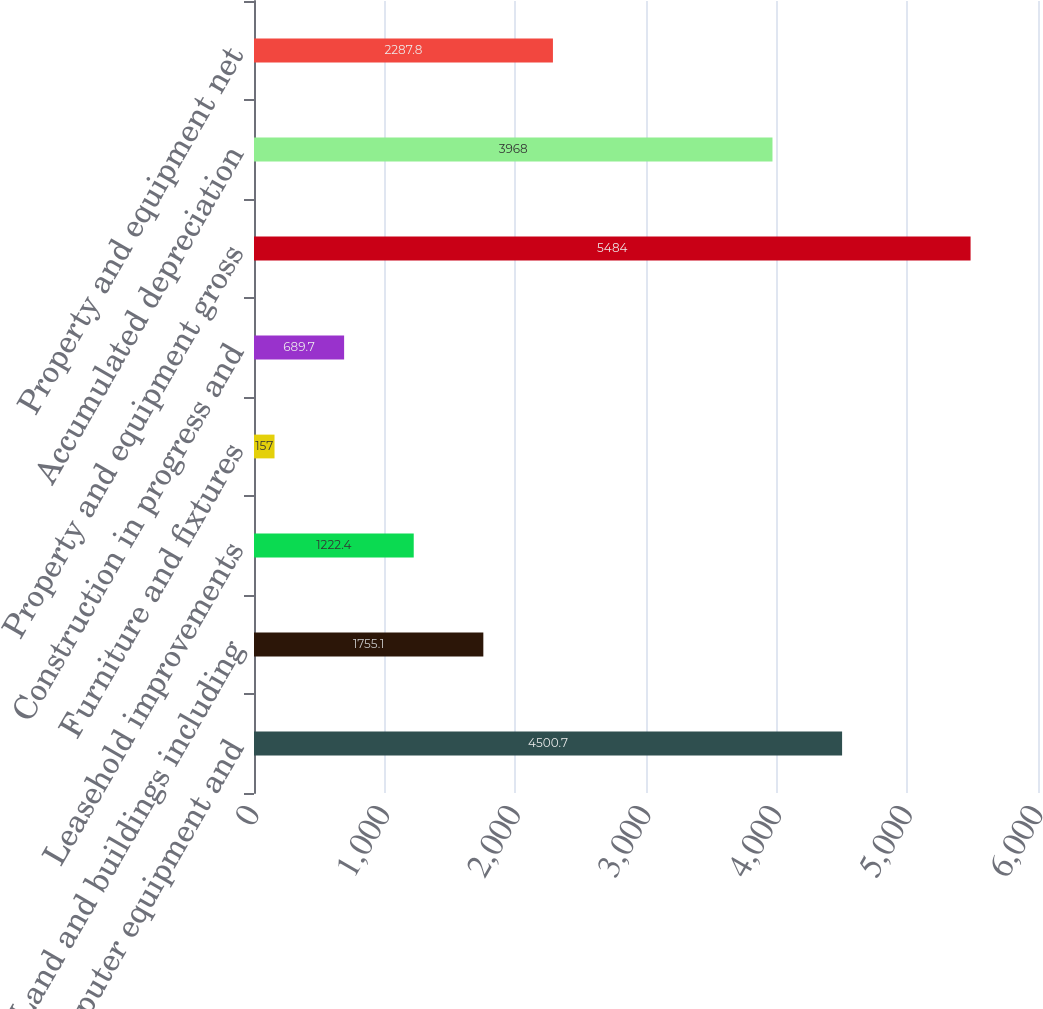Convert chart. <chart><loc_0><loc_0><loc_500><loc_500><bar_chart><fcel>Computer equipment and<fcel>Land and buildings including<fcel>Leasehold improvements<fcel>Furniture and fixtures<fcel>Construction in progress and<fcel>Property and equipment gross<fcel>Accumulated depreciation<fcel>Property and equipment net<nl><fcel>4500.7<fcel>1755.1<fcel>1222.4<fcel>157<fcel>689.7<fcel>5484<fcel>3968<fcel>2287.8<nl></chart> 